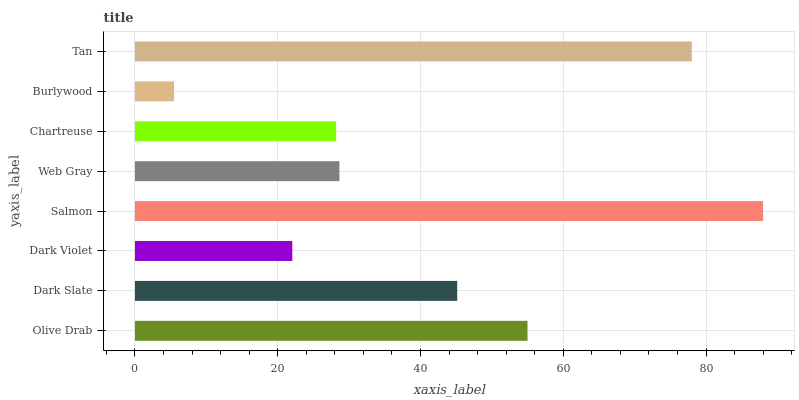Is Burlywood the minimum?
Answer yes or no. Yes. Is Salmon the maximum?
Answer yes or no. Yes. Is Dark Slate the minimum?
Answer yes or no. No. Is Dark Slate the maximum?
Answer yes or no. No. Is Olive Drab greater than Dark Slate?
Answer yes or no. Yes. Is Dark Slate less than Olive Drab?
Answer yes or no. Yes. Is Dark Slate greater than Olive Drab?
Answer yes or no. No. Is Olive Drab less than Dark Slate?
Answer yes or no. No. Is Dark Slate the high median?
Answer yes or no. Yes. Is Web Gray the low median?
Answer yes or no. Yes. Is Web Gray the high median?
Answer yes or no. No. Is Dark Slate the low median?
Answer yes or no. No. 